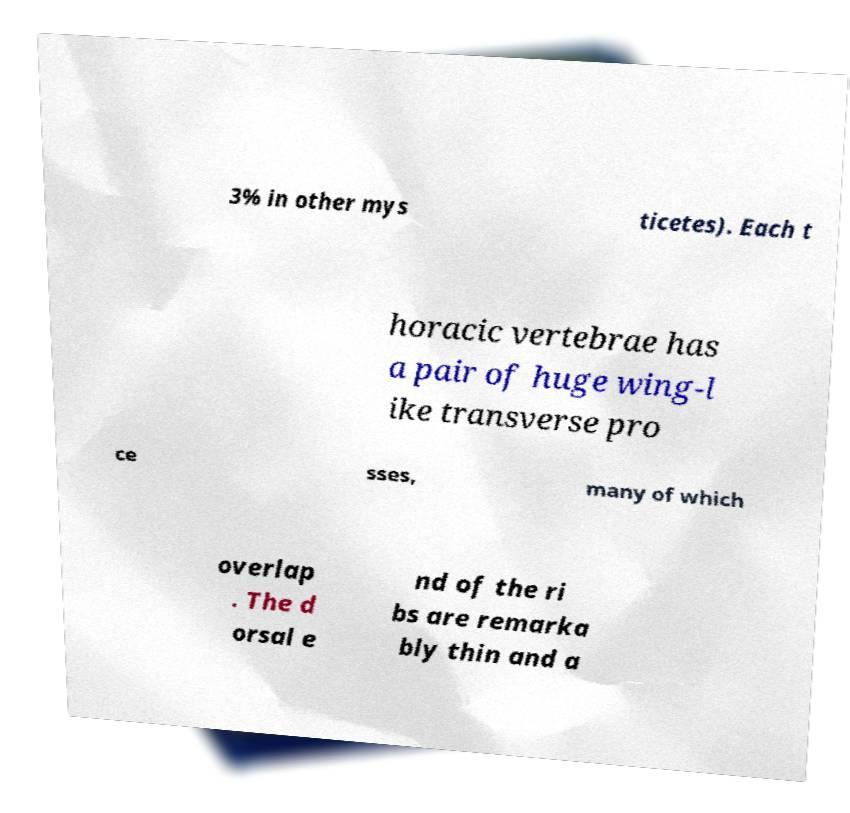For documentation purposes, I need the text within this image transcribed. Could you provide that? 3% in other mys ticetes). Each t horacic vertebrae has a pair of huge wing-l ike transverse pro ce sses, many of which overlap . The d orsal e nd of the ri bs are remarka bly thin and a 